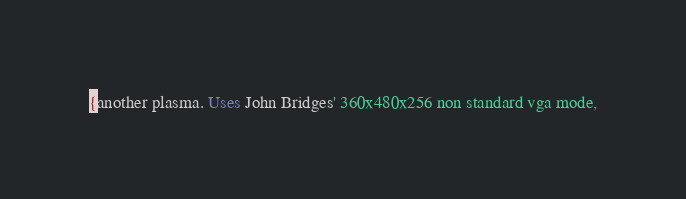<code> <loc_0><loc_0><loc_500><loc_500><_Pascal_>{another plasma. Uses John Bridges' 360x480x256 non standard vga mode,</code> 